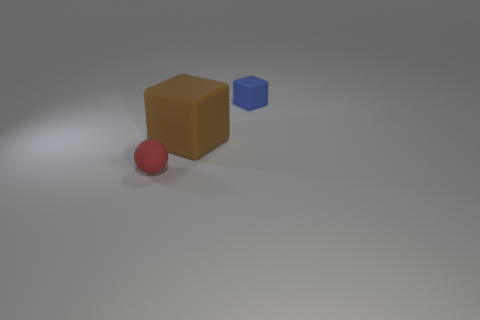Add 2 big yellow metal cubes. How many objects exist? 5 Subtract all balls. How many objects are left? 2 Add 3 tiny purple rubber spheres. How many tiny purple rubber spheres exist? 3 Subtract 1 blue blocks. How many objects are left? 2 Subtract all cyan metallic cylinders. Subtract all big blocks. How many objects are left? 2 Add 2 brown matte cubes. How many brown matte cubes are left? 3 